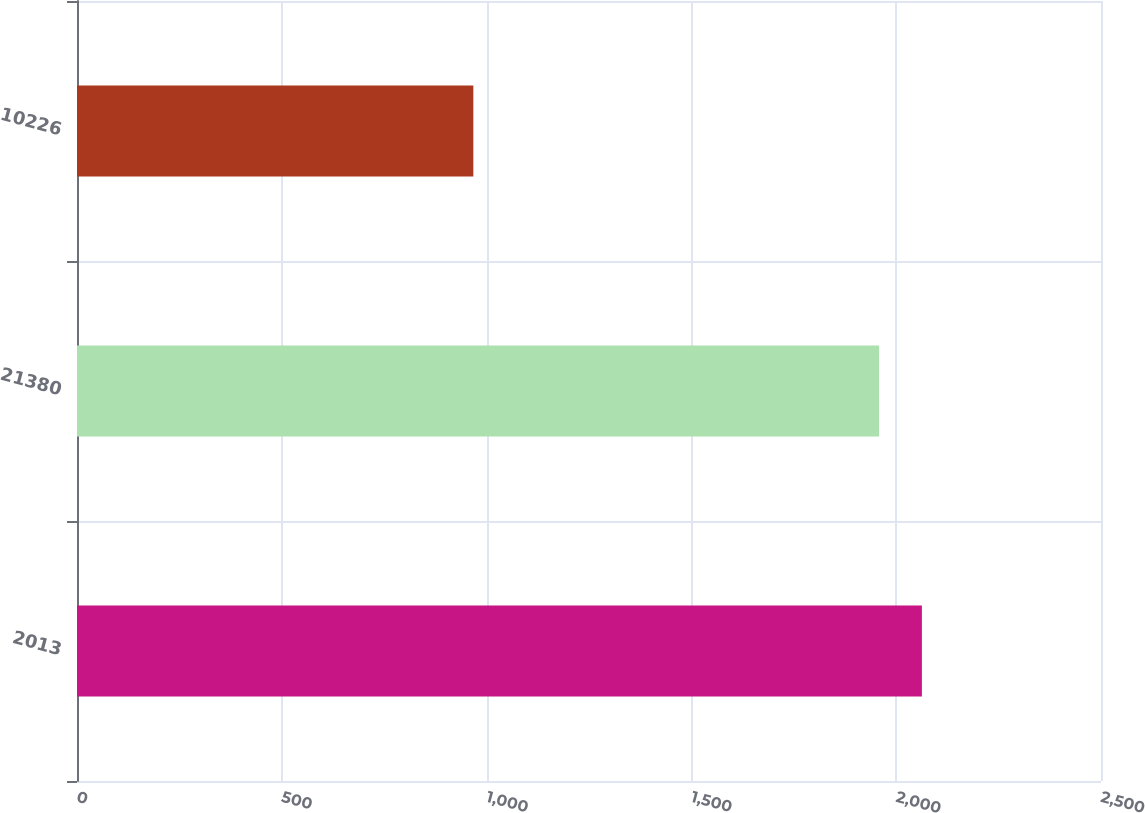Convert chart. <chart><loc_0><loc_0><loc_500><loc_500><bar_chart><fcel>2013<fcel>21380<fcel>10226<nl><fcel>2062.74<fcel>1958.3<fcel>967.6<nl></chart> 